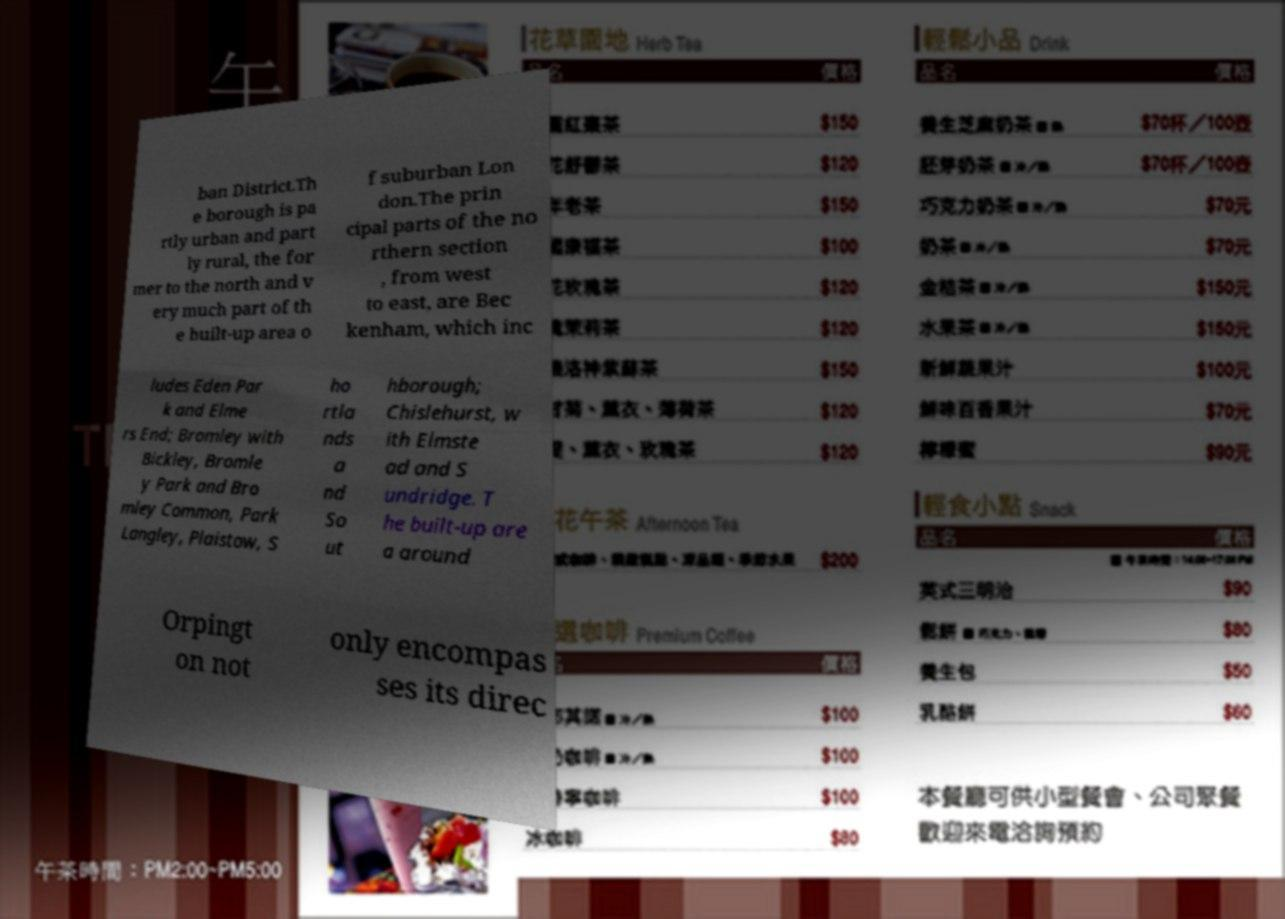Could you extract and type out the text from this image? ban District.Th e borough is pa rtly urban and part ly rural, the for mer to the north and v ery much part of th e built-up area o f suburban Lon don.The prin cipal parts of the no rthern section , from west to east, are Bec kenham, which inc ludes Eden Par k and Elme rs End; Bromley with Bickley, Bromle y Park and Bro mley Common, Park Langley, Plaistow, S ho rtla nds a nd So ut hborough; Chislehurst, w ith Elmste ad and S undridge. T he built-up are a around Orpingt on not only encompas ses its direc 